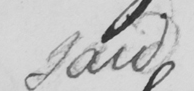Please transcribe the handwritten text in this image. said 